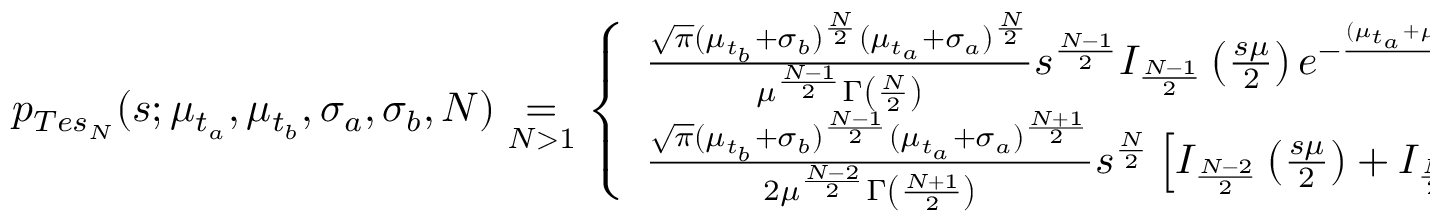<formula> <loc_0><loc_0><loc_500><loc_500>\begin{array} { r } { p _ { T e s _ { N } } ( s ; \mu _ { t _ { a } } , \mu _ { t _ { b } } , \sigma _ { a } , \sigma _ { b } , N ) \underset { N > 1 } { = } \left \{ \begin{array} { l l l } { \frac { \sqrt { \pi } ( \mu _ { t _ { b } } + \sigma _ { b } ) ^ { \frac { N } { 2 } } ( \mu _ { t _ { a } } + \sigma _ { a } ) ^ { \frac { N } { 2 } } } { \mu ^ { \frac { N - 1 } { 2 } } \Gamma \left ( \frac { N } { 2 } \right ) } s ^ { \frac { N - 1 } { 2 } } I _ { \frac { N - 1 } { 2 } } \left ( \frac { s \mu } { 2 } \right ) e ^ { - \frac { ( \mu _ { t _ { a } } + \mu _ { t _ { b } } + \sigma _ { a } + \sigma _ { b } ) } { 2 } s } } & { N e v e n } \\ { \frac { \sqrt { \pi } ( \mu _ { t _ { b } } + \sigma _ { b } ) ^ { \frac { N - 1 } { 2 } } ( \mu _ { t _ { a } } + \sigma _ { a } ) ^ { \frac { N + 1 } { 2 } } } { 2 \mu ^ { \frac { N - 2 } { 2 } } \Gamma \left ( \frac { N + 1 } { 2 } \right ) } s ^ { \frac { N } { 2 } } \left [ I _ { \frac { N - 2 } { 2 } } \left ( \frac { s \mu } { 2 } \right ) + I _ { \frac { N } { 2 } } \left ( \frac { s \mu } { 2 } \right ) \right ] e ^ { - \frac { ( \mu _ { t _ { a } } + \mu _ { t _ { b } } + \sigma _ { a } + \sigma _ { b } ) } { 2 } s } } & { N o d d \, . } \end{array} } \end{array}</formula> 